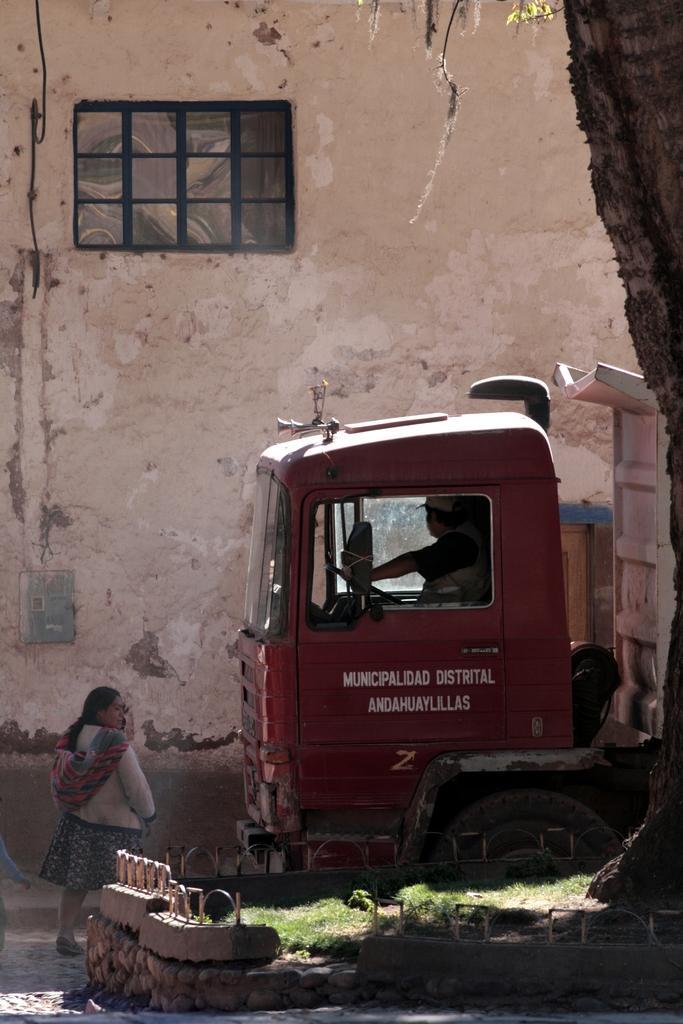Describe this image in one or two sentences. As we can see in the image there is wall, window, truck, grass and two people. 